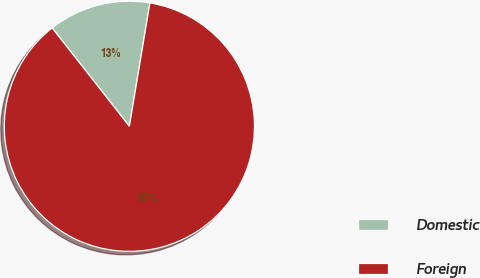Convert chart. <chart><loc_0><loc_0><loc_500><loc_500><pie_chart><fcel>Domestic<fcel>Foreign<nl><fcel>13.22%<fcel>86.78%<nl></chart> 